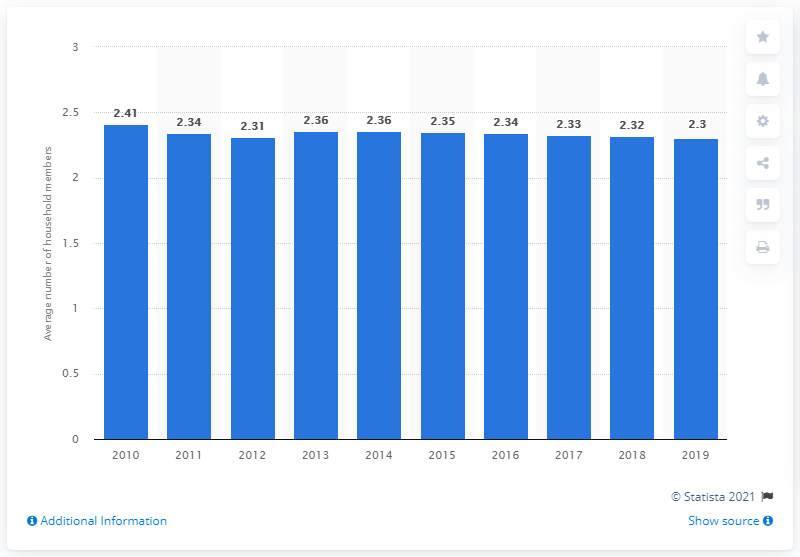Give some essential details in this illustration. In Italy in 2010, the average number of households was 2.41. 